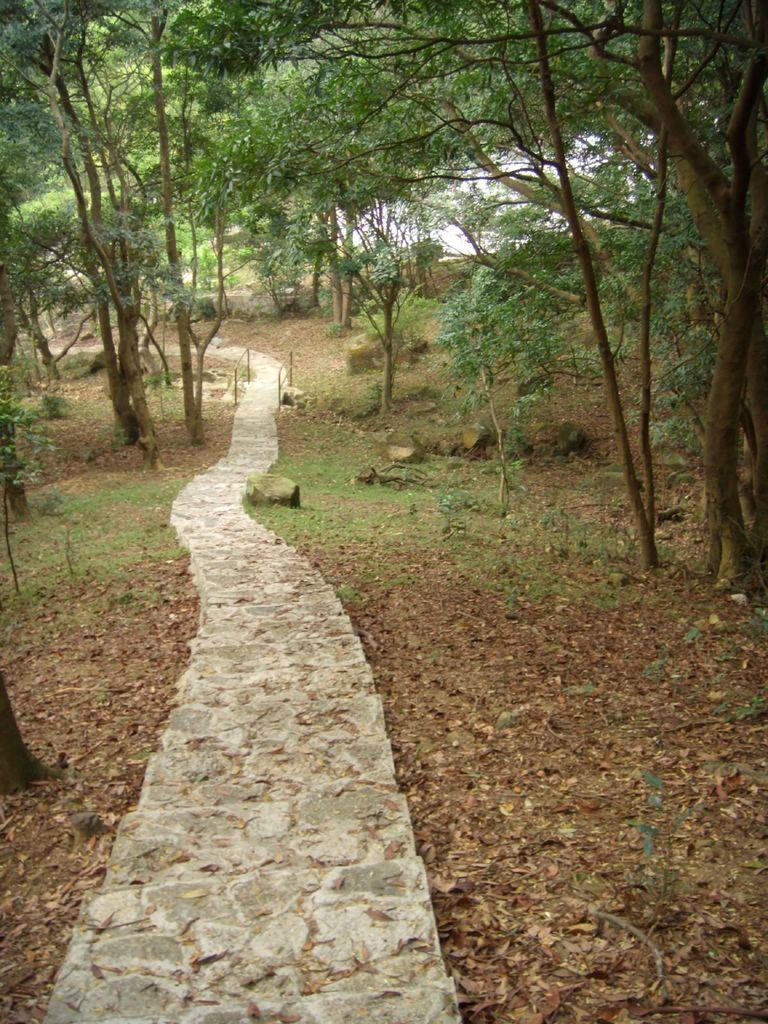What type of path is visible in the image? There is a long walking path in the image. What can be seen on either side of the path? Trees and grass are visible on either side of the path. What type of garden can be seen in the image? There is no garden present in the image; it features a long walking path with trees and grass on either side. 